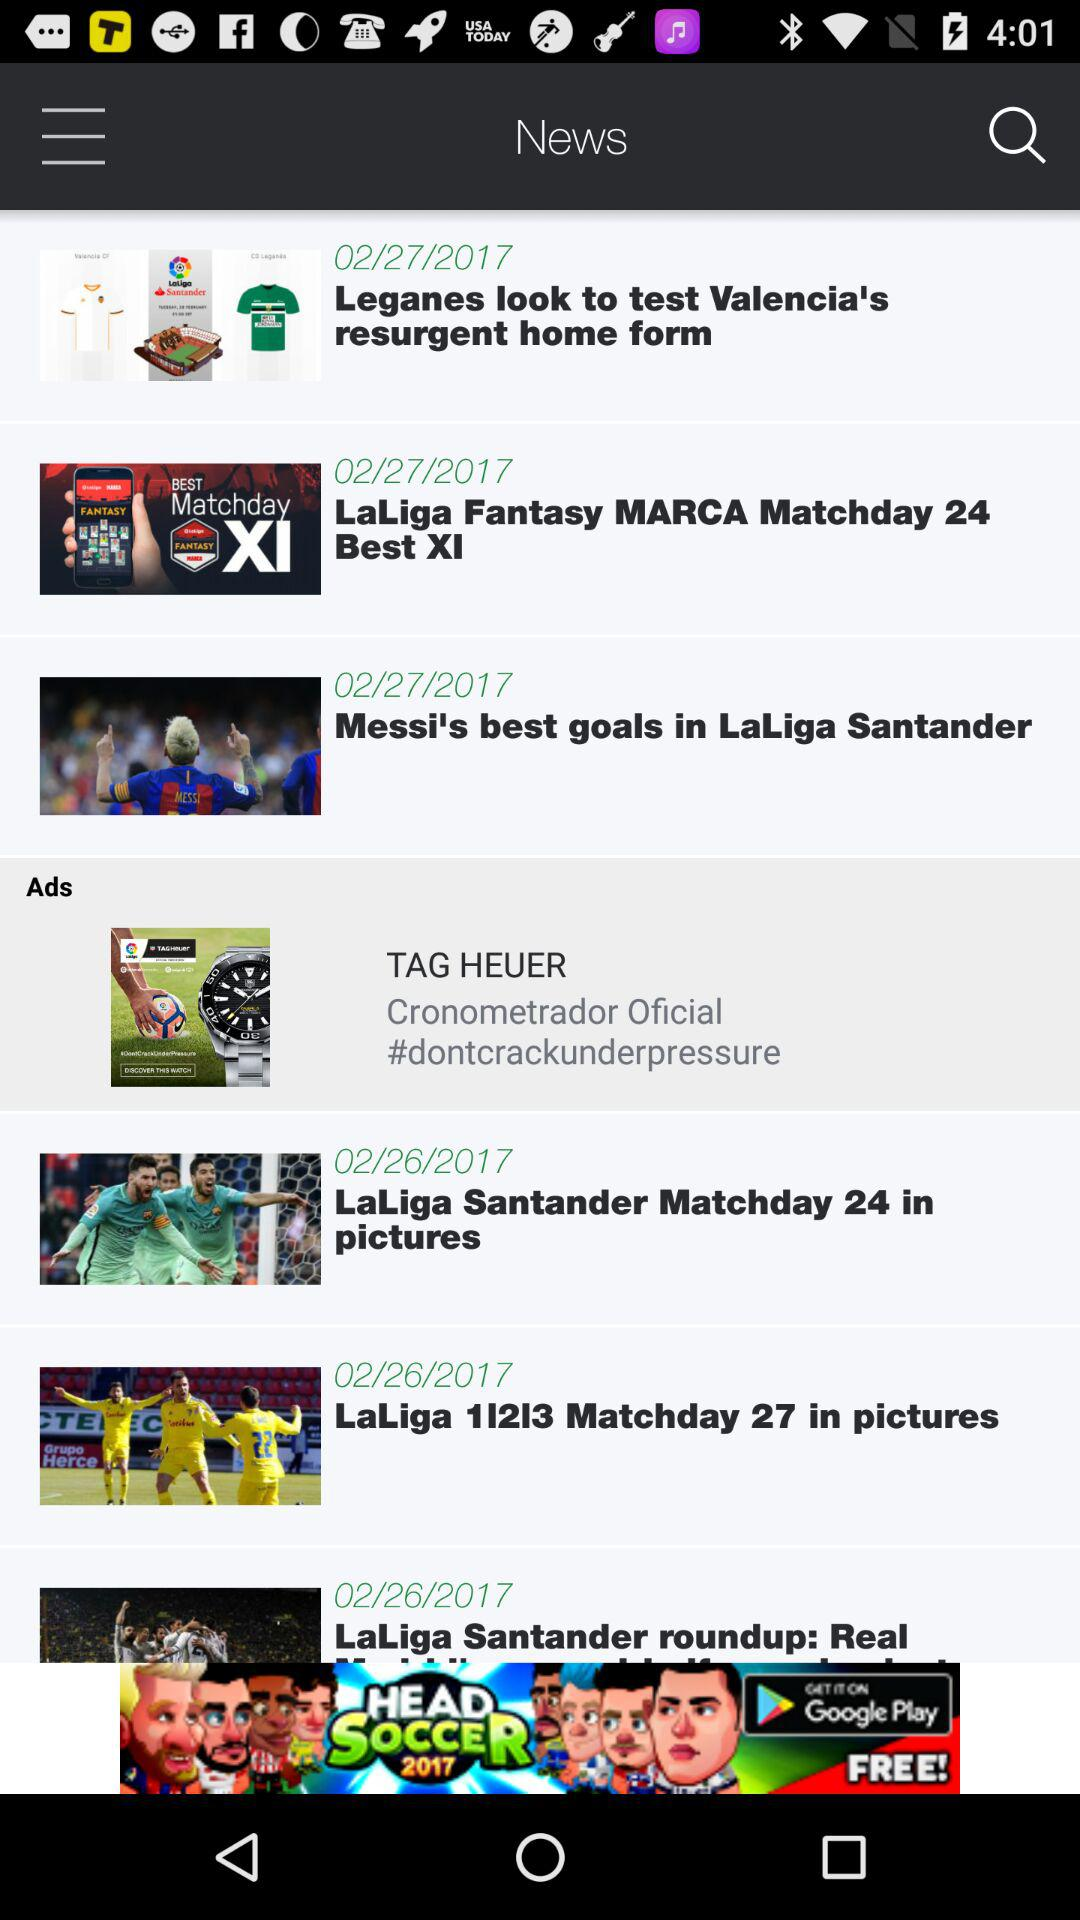On which date was the news "Messi's best goals in LaLiga Santander" posted? The news "Messi's best goals in LaLiga Santander" was posted on February 27, 2017. 